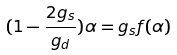<formula> <loc_0><loc_0><loc_500><loc_500>( 1 - \frac { 2 g _ { s } } { g _ { d } } ) \alpha = g _ { s } f ( \alpha )</formula> 